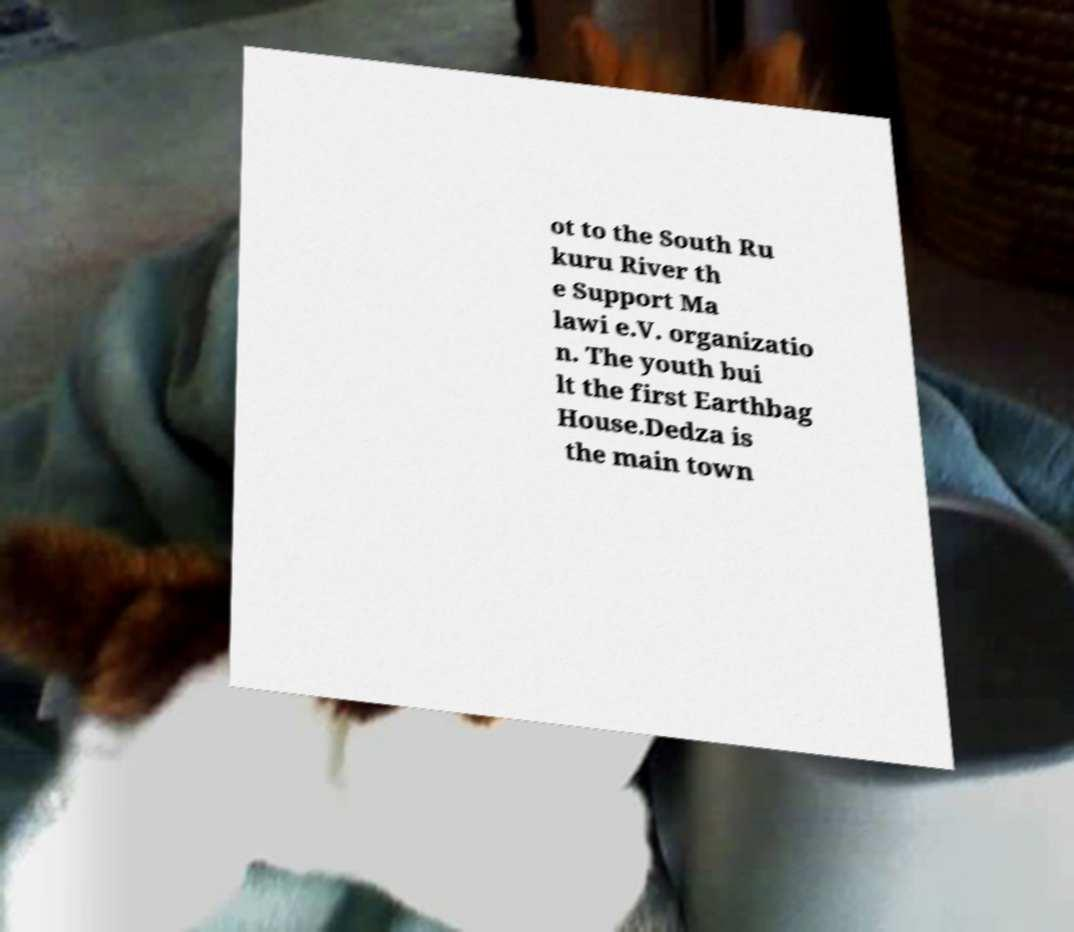Can you accurately transcribe the text from the provided image for me? ot to the South Ru kuru River th e Support Ma lawi e.V. organizatio n. The youth bui lt the first Earthbag House.Dedza is the main town 